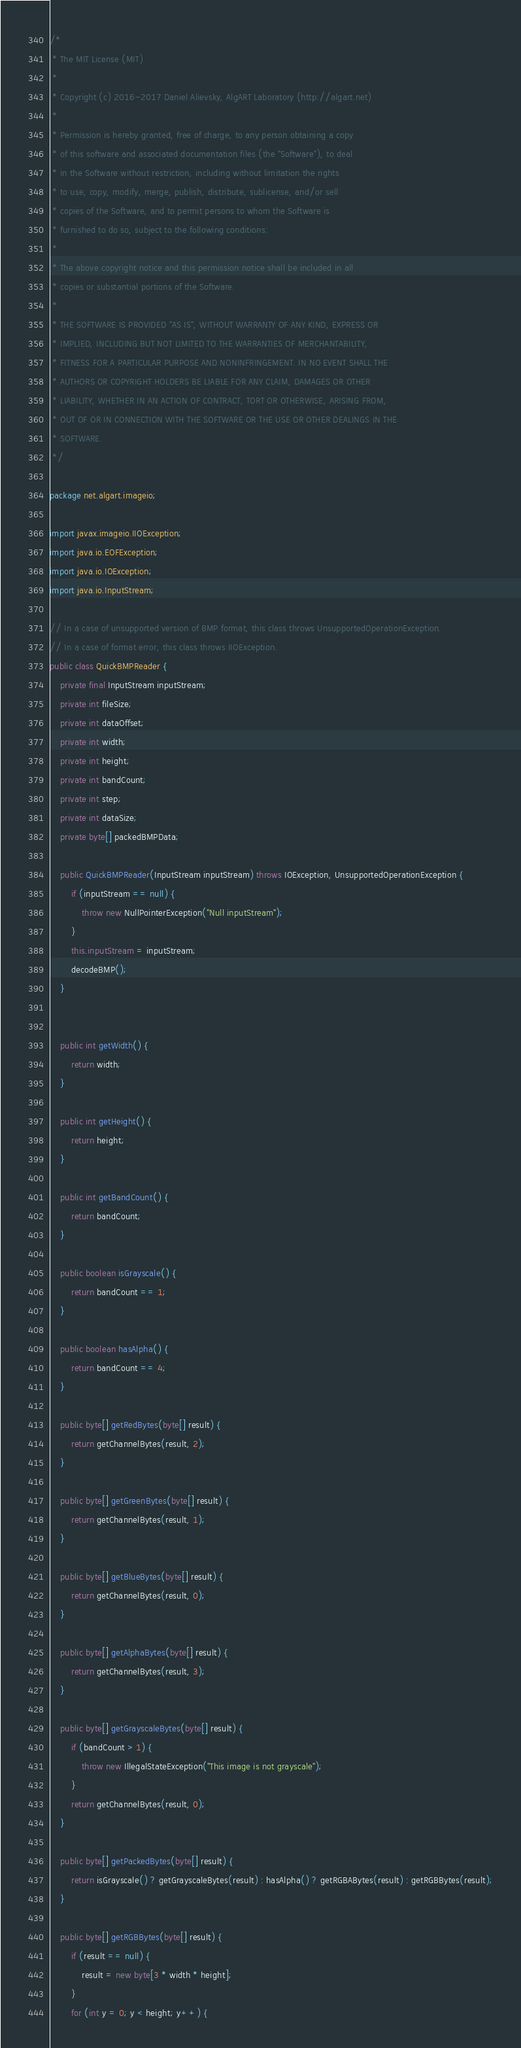Convert code to text. <code><loc_0><loc_0><loc_500><loc_500><_Java_>/*
 * The MIT License (MIT)
 *
 * Copyright (c) 2016-2017 Daniel Alievsky, AlgART Laboratory (http://algart.net)
 *
 * Permission is hereby granted, free of charge, to any person obtaining a copy
 * of this software and associated documentation files (the "Software"), to deal
 * in the Software without restriction, including without limitation the rights
 * to use, copy, modify, merge, publish, distribute, sublicense, and/or sell
 * copies of the Software, and to permit persons to whom the Software is
 * furnished to do so, subject to the following conditions:
 *
 * The above copyright notice and this permission notice shall be included in all
 * copies or substantial portions of the Software.
 *
 * THE SOFTWARE IS PROVIDED "AS IS", WITHOUT WARRANTY OF ANY KIND, EXPRESS OR
 * IMPLIED, INCLUDING BUT NOT LIMITED TO THE WARRANTIES OF MERCHANTABILITY,
 * FITNESS FOR A PARTICULAR PURPOSE AND NONINFRINGEMENT. IN NO EVENT SHALL THE
 * AUTHORS OR COPYRIGHT HOLDERS BE LIABLE FOR ANY CLAIM, DAMAGES OR OTHER
 * LIABILITY, WHETHER IN AN ACTION OF CONTRACT, TORT OR OTHERWISE, ARISING FROM,
 * OUT OF OR IN CONNECTION WITH THE SOFTWARE OR THE USE OR OTHER DEALINGS IN THE
 * SOFTWARE.
 */

package net.algart.imageio;

import javax.imageio.IIOException;
import java.io.EOFException;
import java.io.IOException;
import java.io.InputStream;

// In a case of unsupported version of BMP format, this class throws UnsupportedOperationException.
// In a case of format error, this class throws IIOException.
public class QuickBMPReader {
    private final InputStream inputStream;
    private int fileSize;
    private int dataOffset;
    private int width;
    private int height;
    private int bandCount;
    private int step;
    private int dataSize;
    private byte[] packedBMPData;

    public QuickBMPReader(InputStream inputStream) throws IOException, UnsupportedOperationException {
        if (inputStream == null) {
            throw new NullPointerException("Null inputStream");
        }
        this.inputStream = inputStream;
        decodeBMP();
    }


    public int getWidth() {
        return width;
    }

    public int getHeight() {
        return height;
    }

    public int getBandCount() {
        return bandCount;
    }

    public boolean isGrayscale() {
        return bandCount == 1;
    }

    public boolean hasAlpha() {
        return bandCount == 4;
    }

    public byte[] getRedBytes(byte[] result) {
        return getChannelBytes(result, 2);
    }

    public byte[] getGreenBytes(byte[] result) {
        return getChannelBytes(result, 1);
    }

    public byte[] getBlueBytes(byte[] result) {
        return getChannelBytes(result, 0);
    }

    public byte[] getAlphaBytes(byte[] result) {
        return getChannelBytes(result, 3);
    }

    public byte[] getGrayscaleBytes(byte[] result) {
        if (bandCount > 1) {
            throw new IllegalStateException("This image is not grayscale");
        }
        return getChannelBytes(result, 0);
    }

    public byte[] getPackedBytes(byte[] result) {
        return isGrayscale() ? getGrayscaleBytes(result) : hasAlpha() ? getRGBABytes(result) : getRGBBytes(result);
    }

    public byte[] getRGBBytes(byte[] result) {
        if (result == null) {
            result = new byte[3 * width * height];
        }
        for (int y = 0; y < height; y++) {</code> 